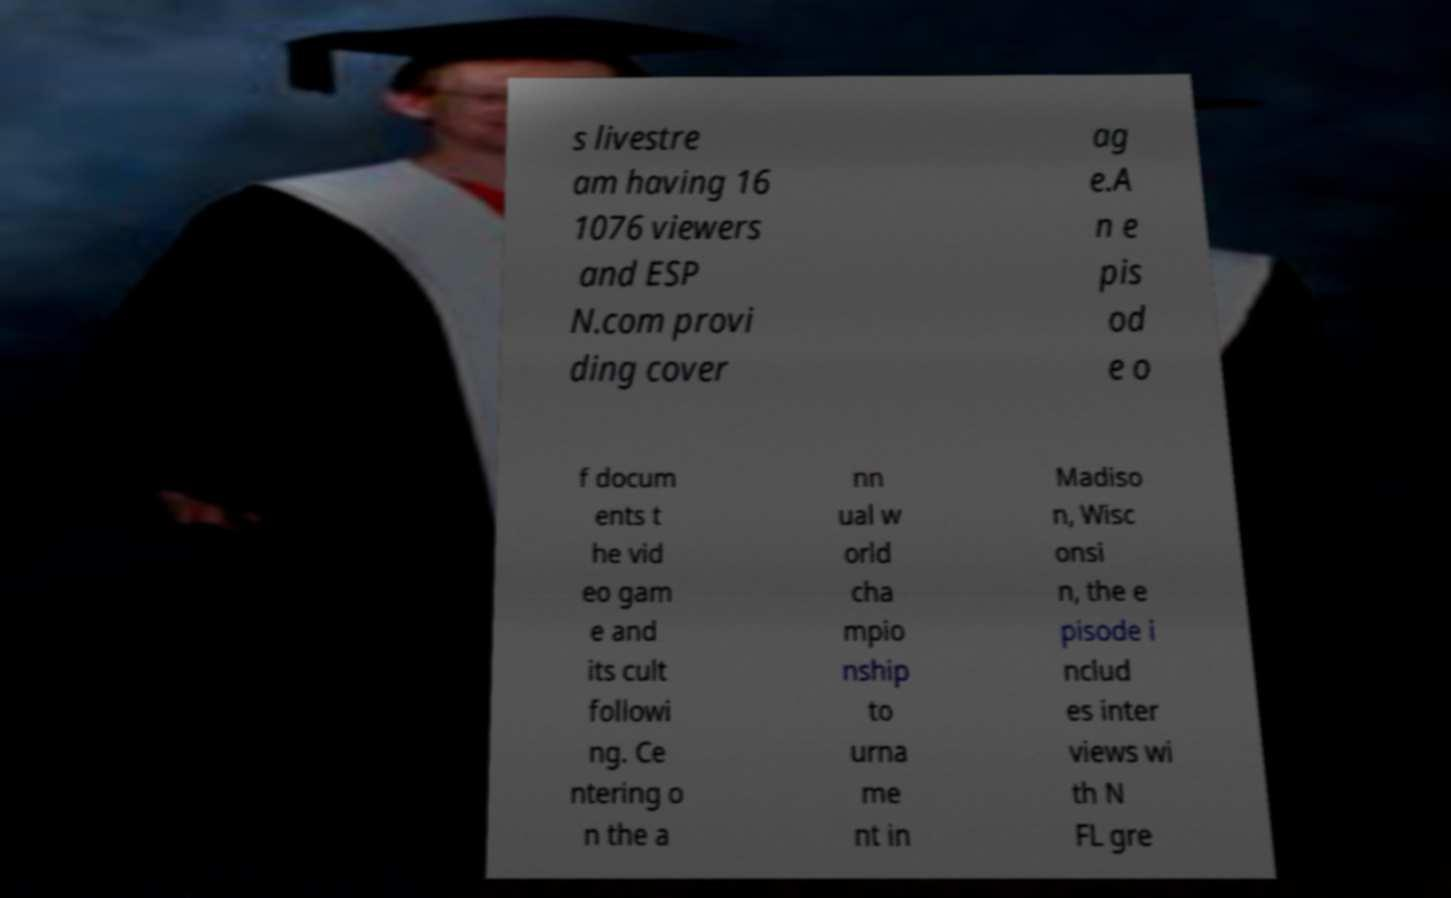What messages or text are displayed in this image? I need them in a readable, typed format. s livestre am having 16 1076 viewers and ESP N.com provi ding cover ag e.A n e pis od e o f docum ents t he vid eo gam e and its cult followi ng. Ce ntering o n the a nn ual w orld cha mpio nship to urna me nt in Madiso n, Wisc onsi n, the e pisode i nclud es inter views wi th N FL gre 